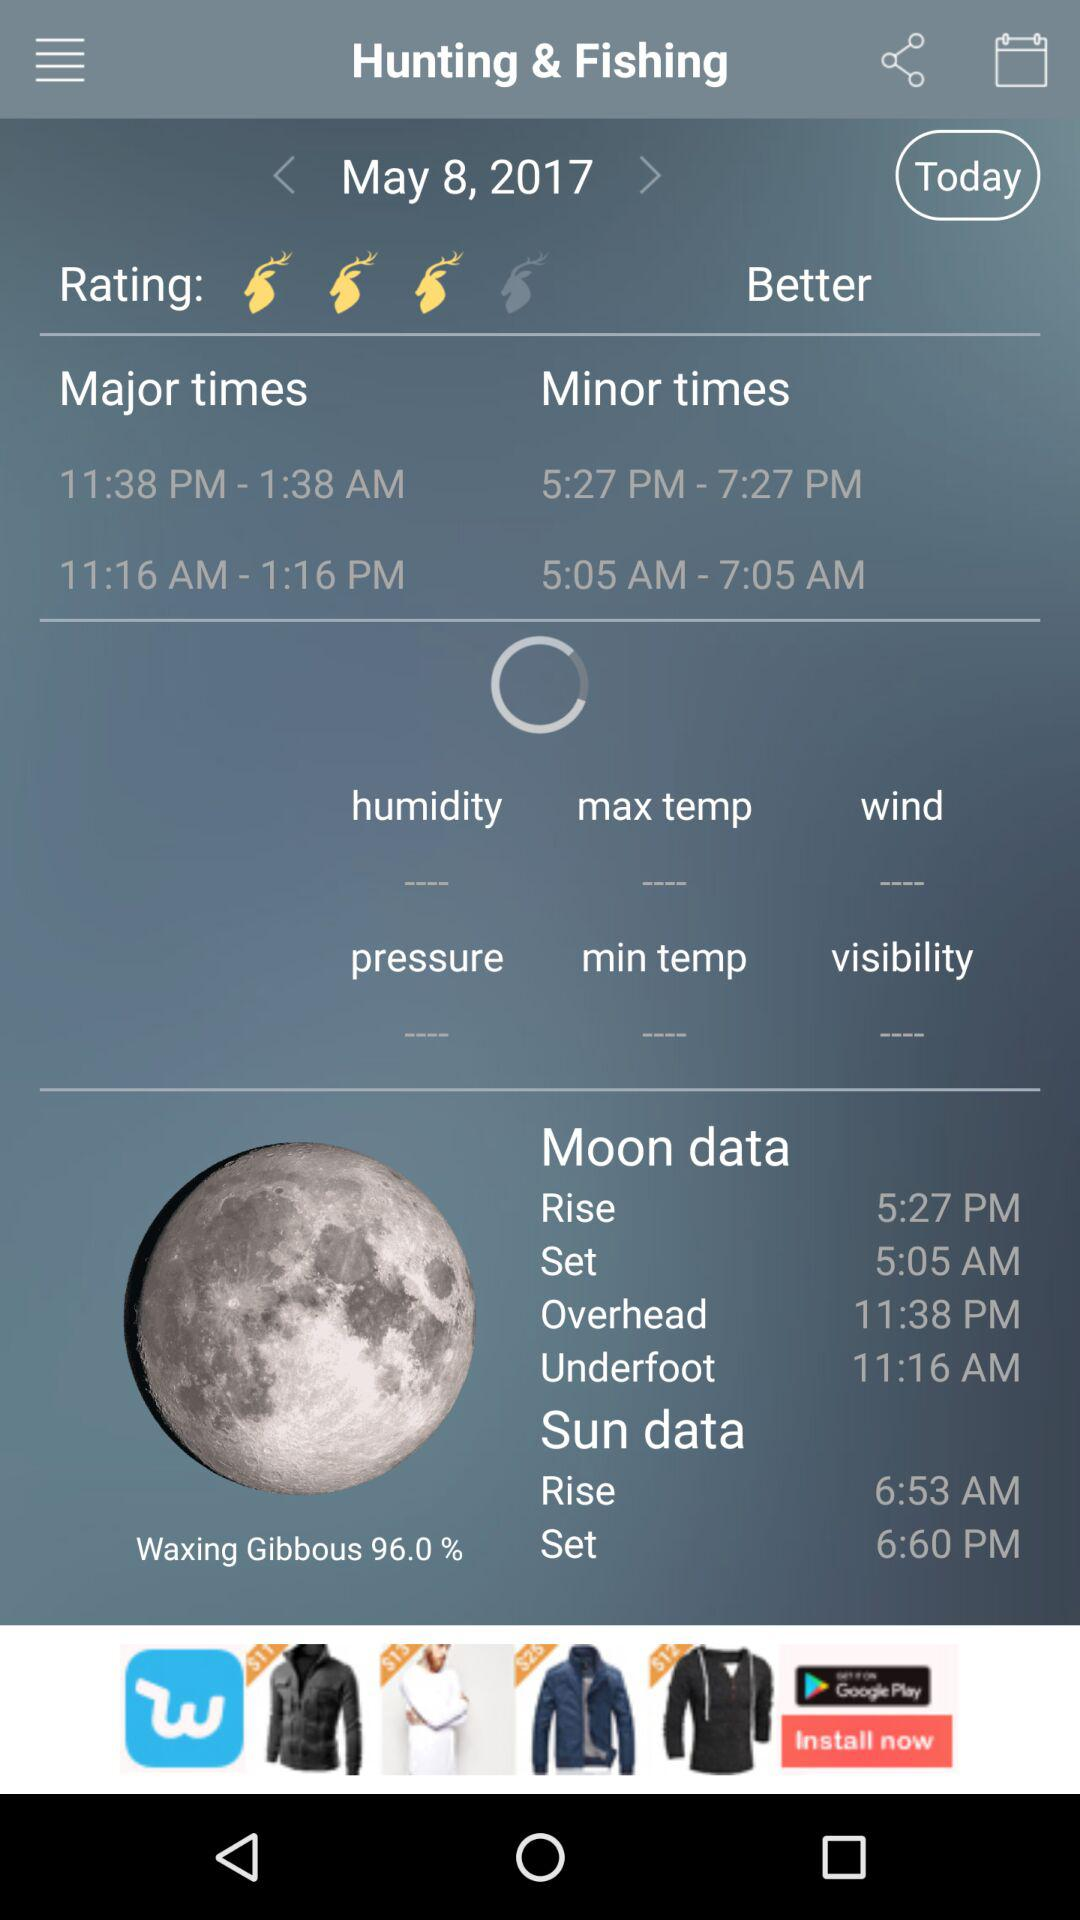What is the sunset time? The sunset time is 6:60 PM. 